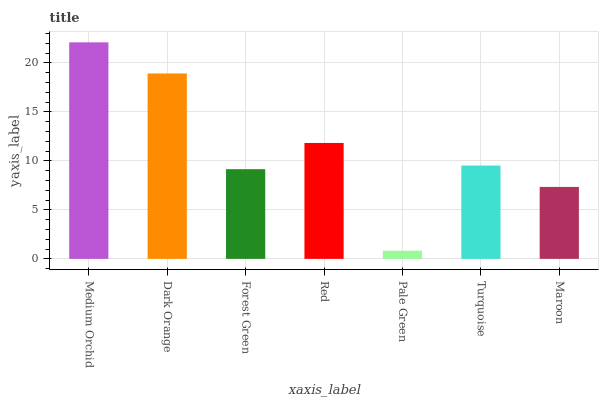Is Pale Green the minimum?
Answer yes or no. Yes. Is Medium Orchid the maximum?
Answer yes or no. Yes. Is Dark Orange the minimum?
Answer yes or no. No. Is Dark Orange the maximum?
Answer yes or no. No. Is Medium Orchid greater than Dark Orange?
Answer yes or no. Yes. Is Dark Orange less than Medium Orchid?
Answer yes or no. Yes. Is Dark Orange greater than Medium Orchid?
Answer yes or no. No. Is Medium Orchid less than Dark Orange?
Answer yes or no. No. Is Turquoise the high median?
Answer yes or no. Yes. Is Turquoise the low median?
Answer yes or no. Yes. Is Red the high median?
Answer yes or no. No. Is Pale Green the low median?
Answer yes or no. No. 